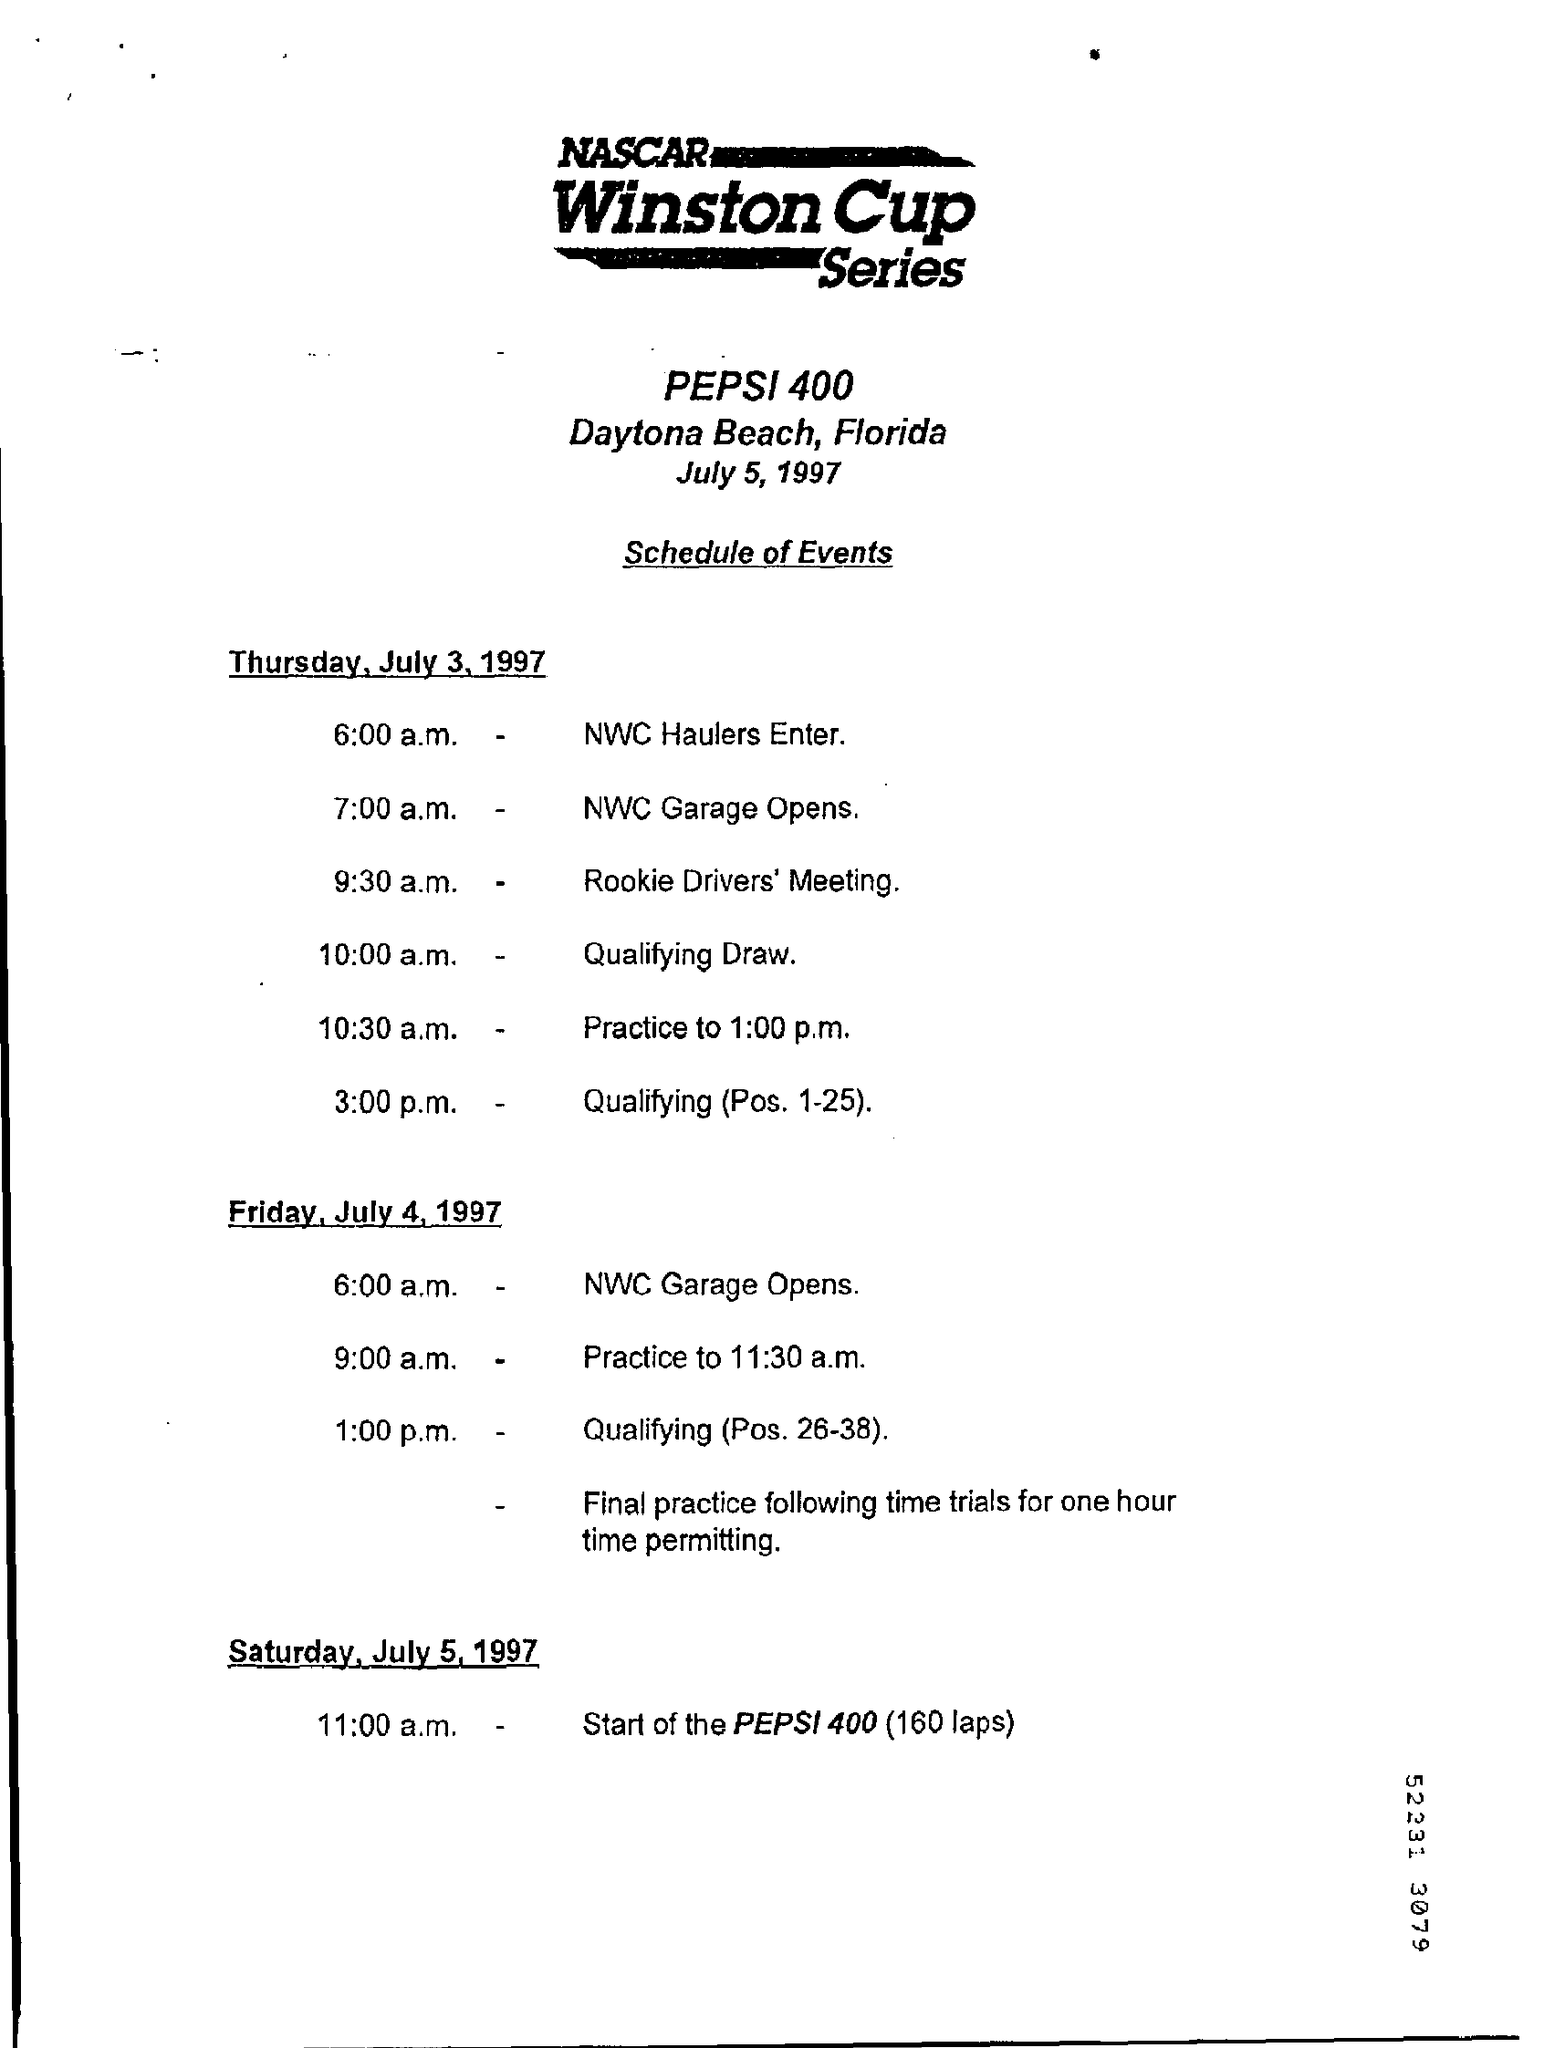Specify some key components in this picture. The Rookie Driver's Meeting is scheduled for 9:30 am. On July 5, 1997, the day was a Saturday. The name of the Nascar series is the Winston Cup series. The state mentioned is Florida. 